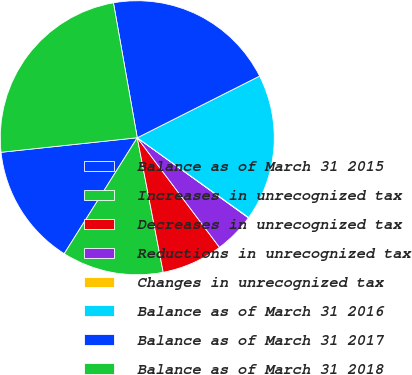<chart> <loc_0><loc_0><loc_500><loc_500><pie_chart><fcel>Balance as of March 31 2015<fcel>Increases in unrecognized tax<fcel>Decreases in unrecognized tax<fcel>Reductions in unrecognized tax<fcel>Changes in unrecognized tax<fcel>Balance as of March 31 2016<fcel>Balance as of March 31 2017<fcel>Balance as of March 31 2018<nl><fcel>14.36%<fcel>11.98%<fcel>7.21%<fcel>4.82%<fcel>0.05%<fcel>17.32%<fcel>20.35%<fcel>23.91%<nl></chart> 